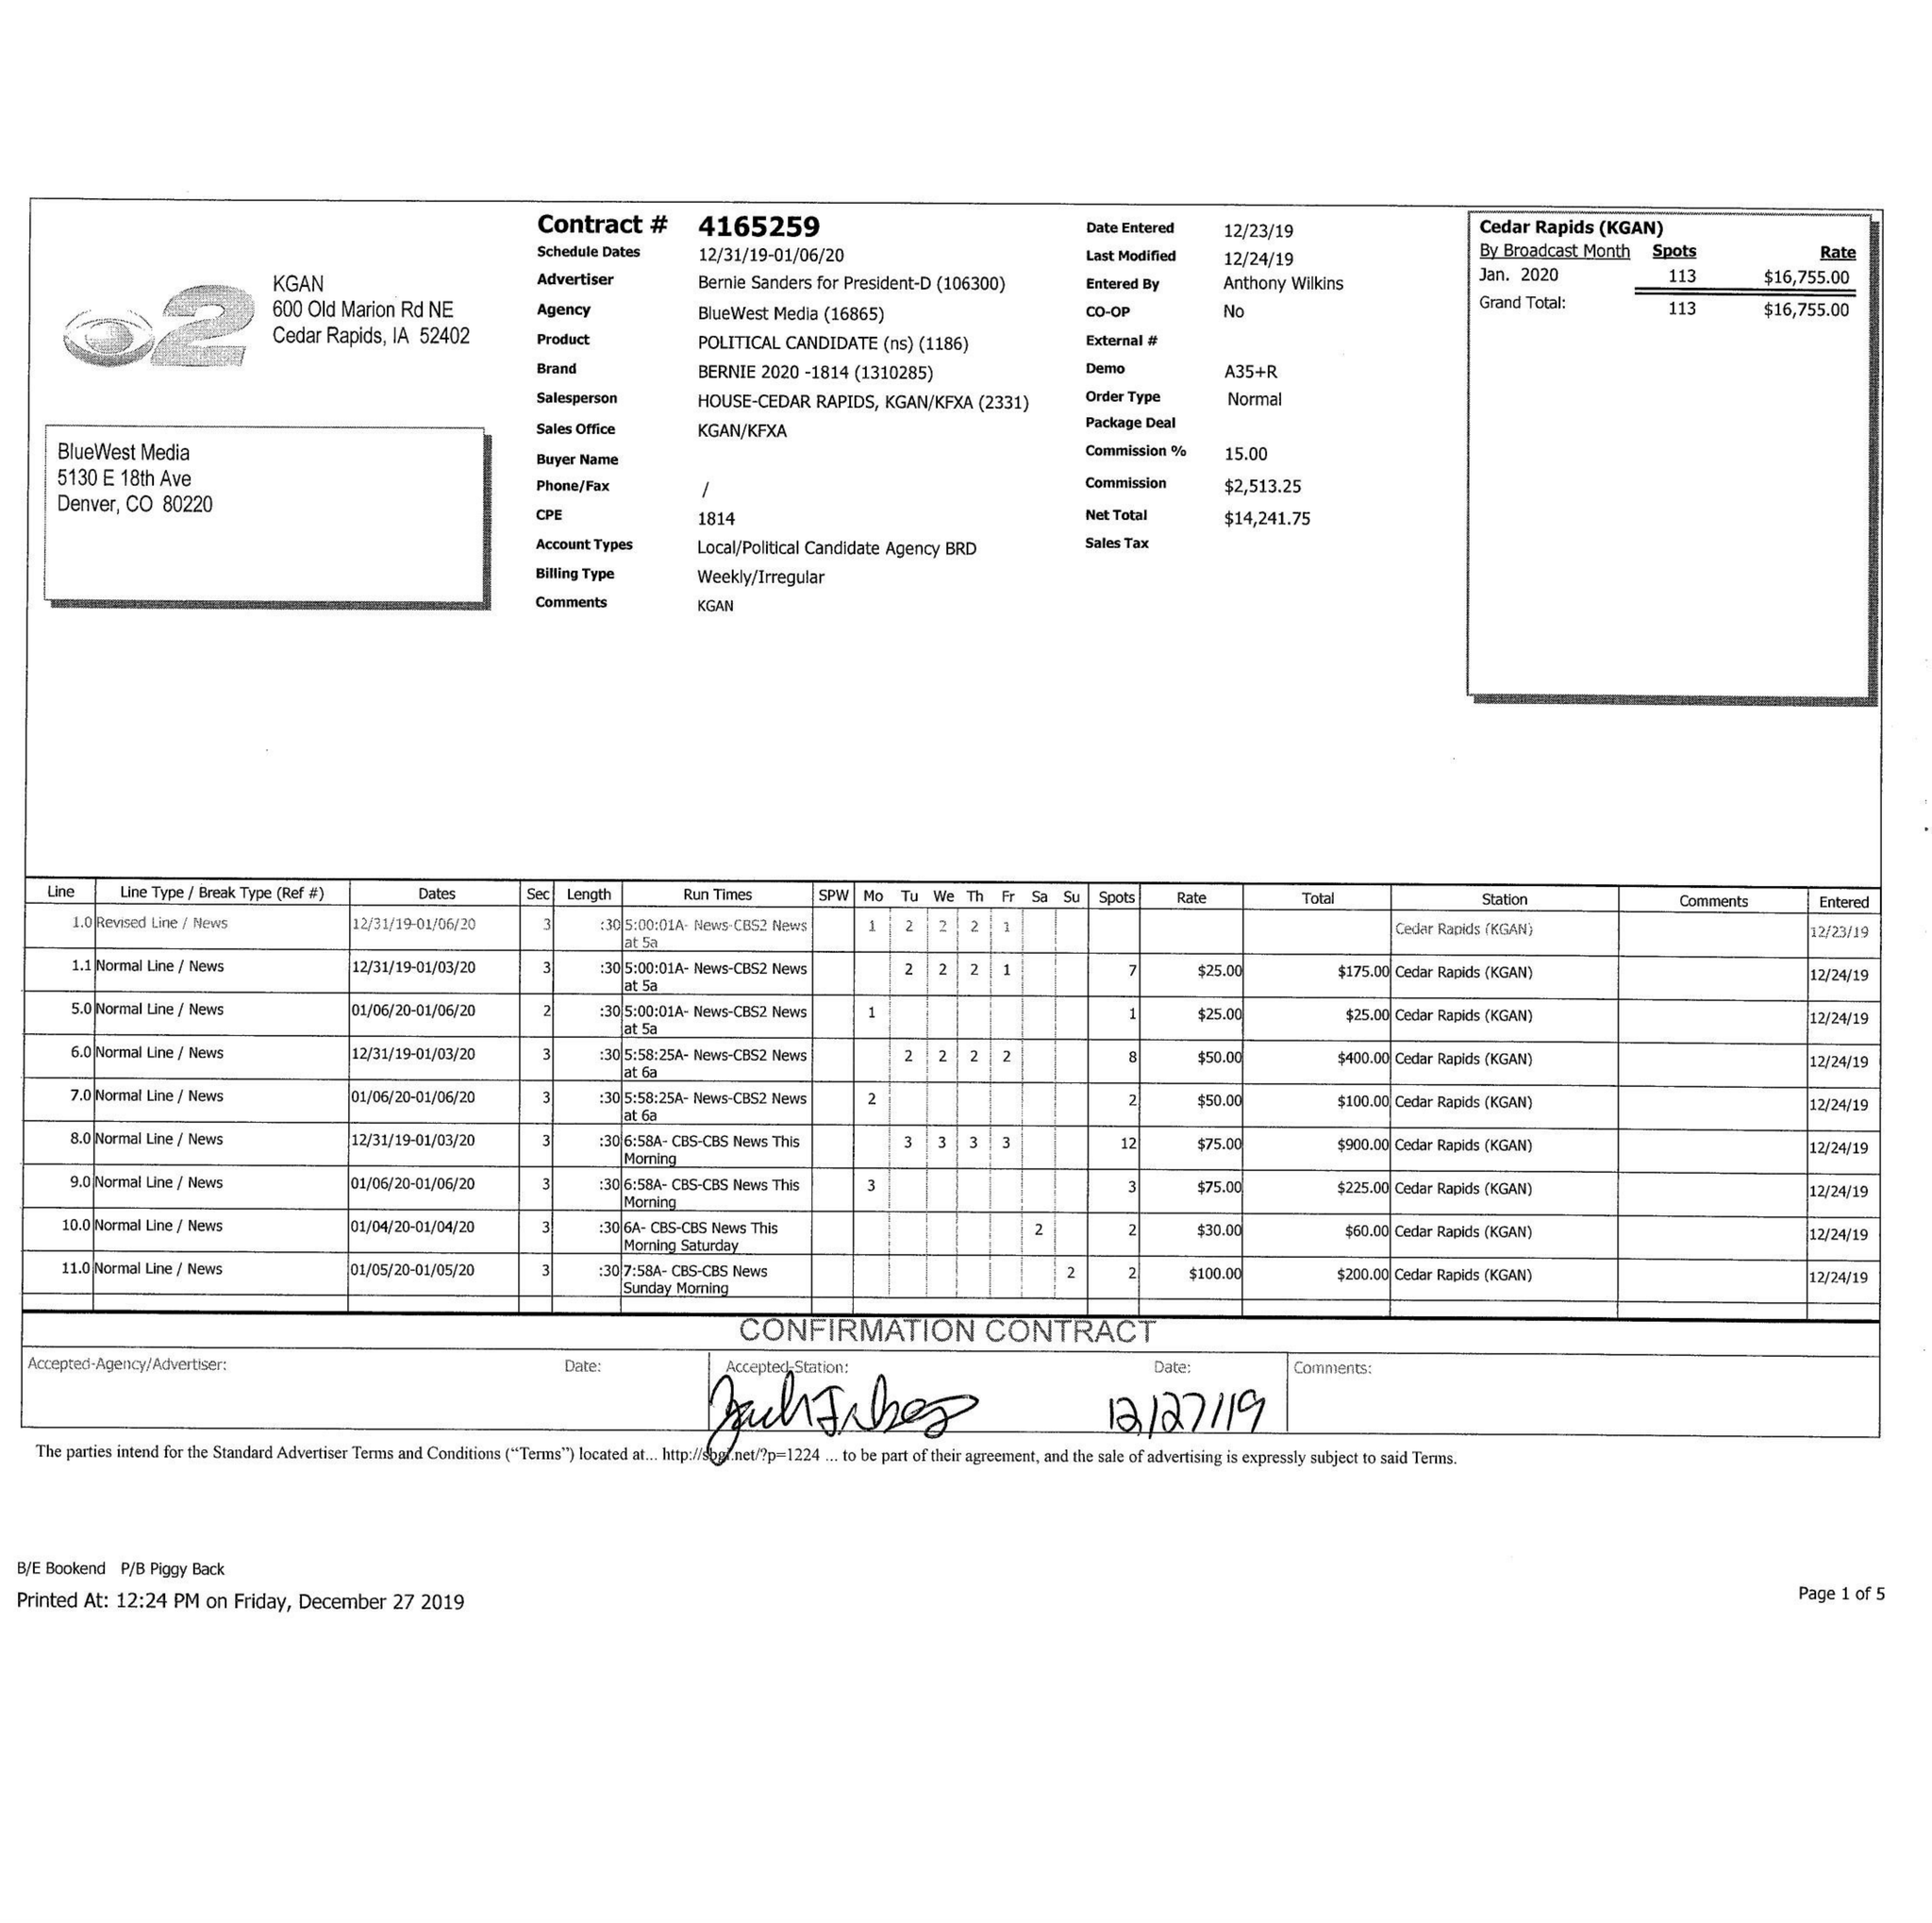What is the value for the flight_from?
Answer the question using a single word or phrase. 12/31/19 